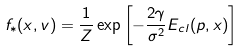<formula> <loc_0><loc_0><loc_500><loc_500>f _ { * } ( x , v ) = { \frac { 1 } { Z } } \exp \left [ - { \frac { 2 \gamma } { \sigma ^ { 2 } } } E _ { c l } ( p , x ) \right ]</formula> 